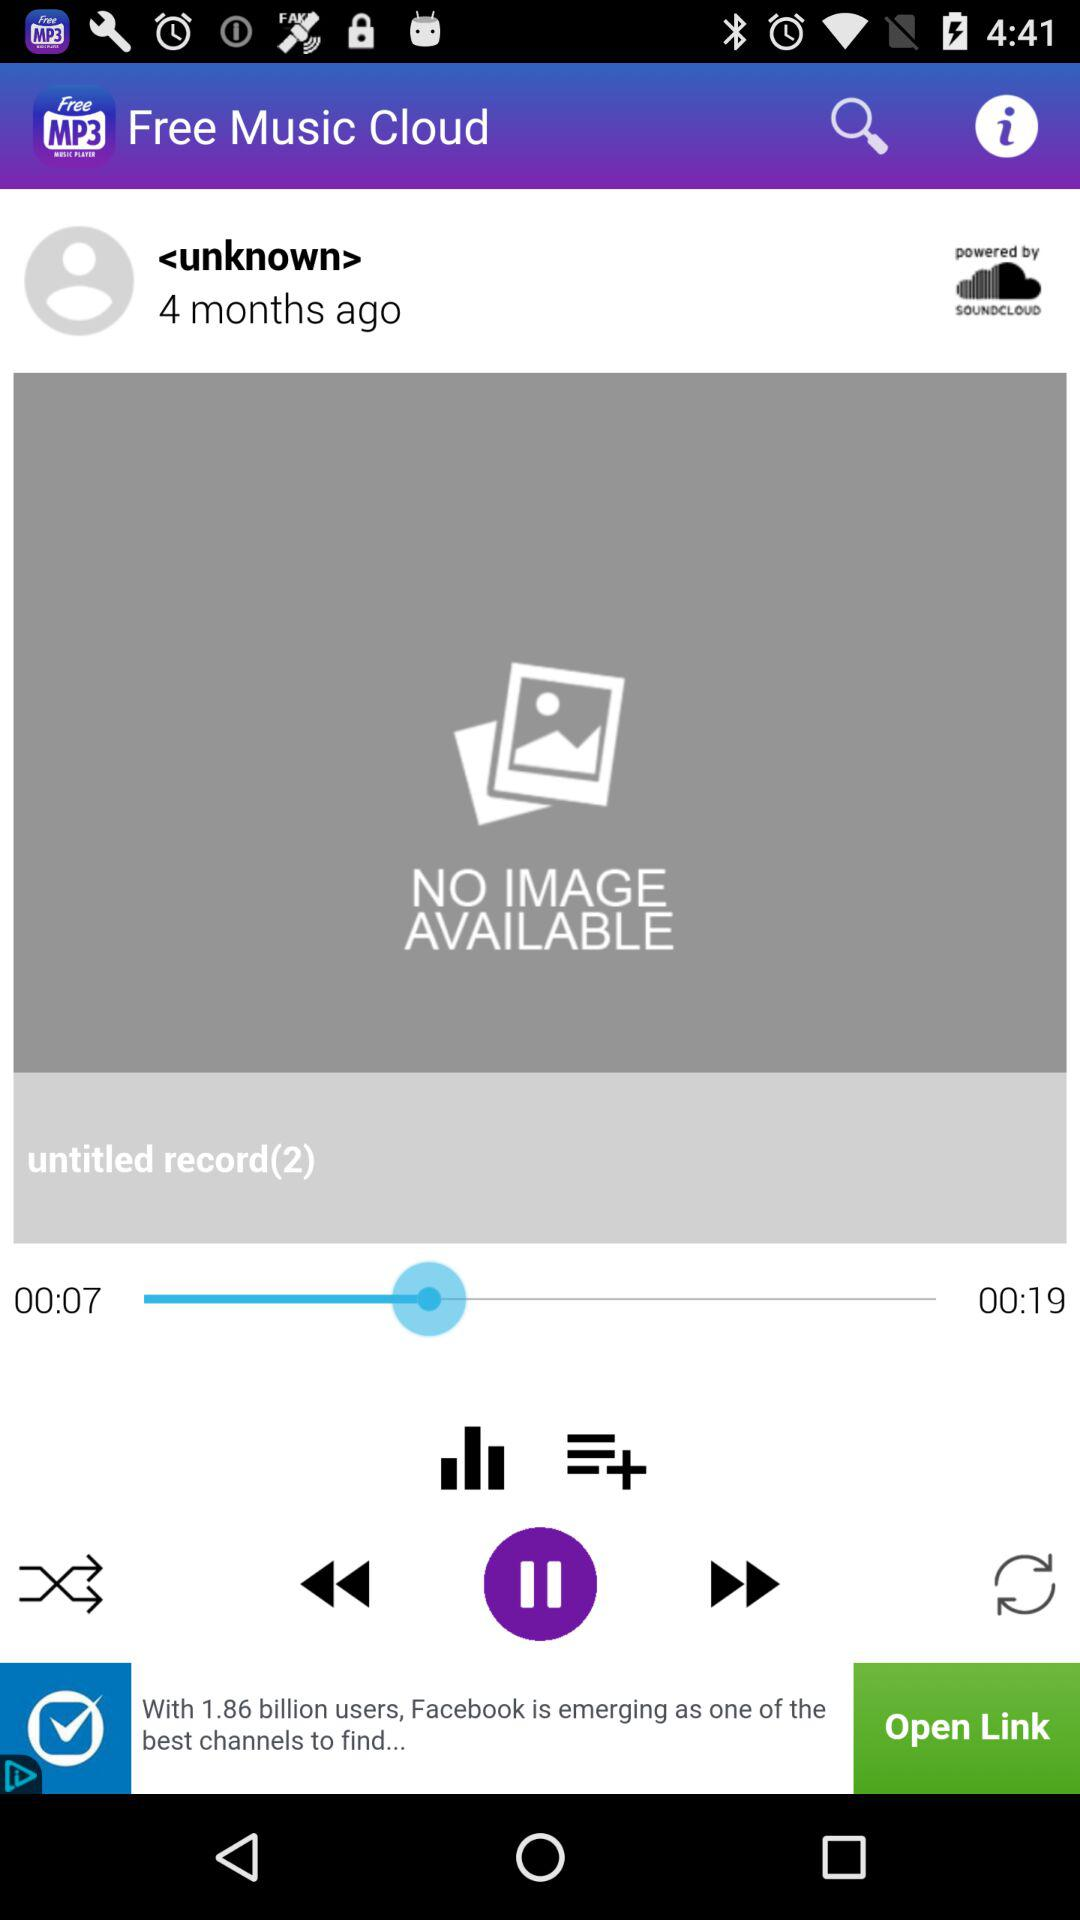How many seconds longer is the second track than the first track?
Answer the question using a single word or phrase. 12 